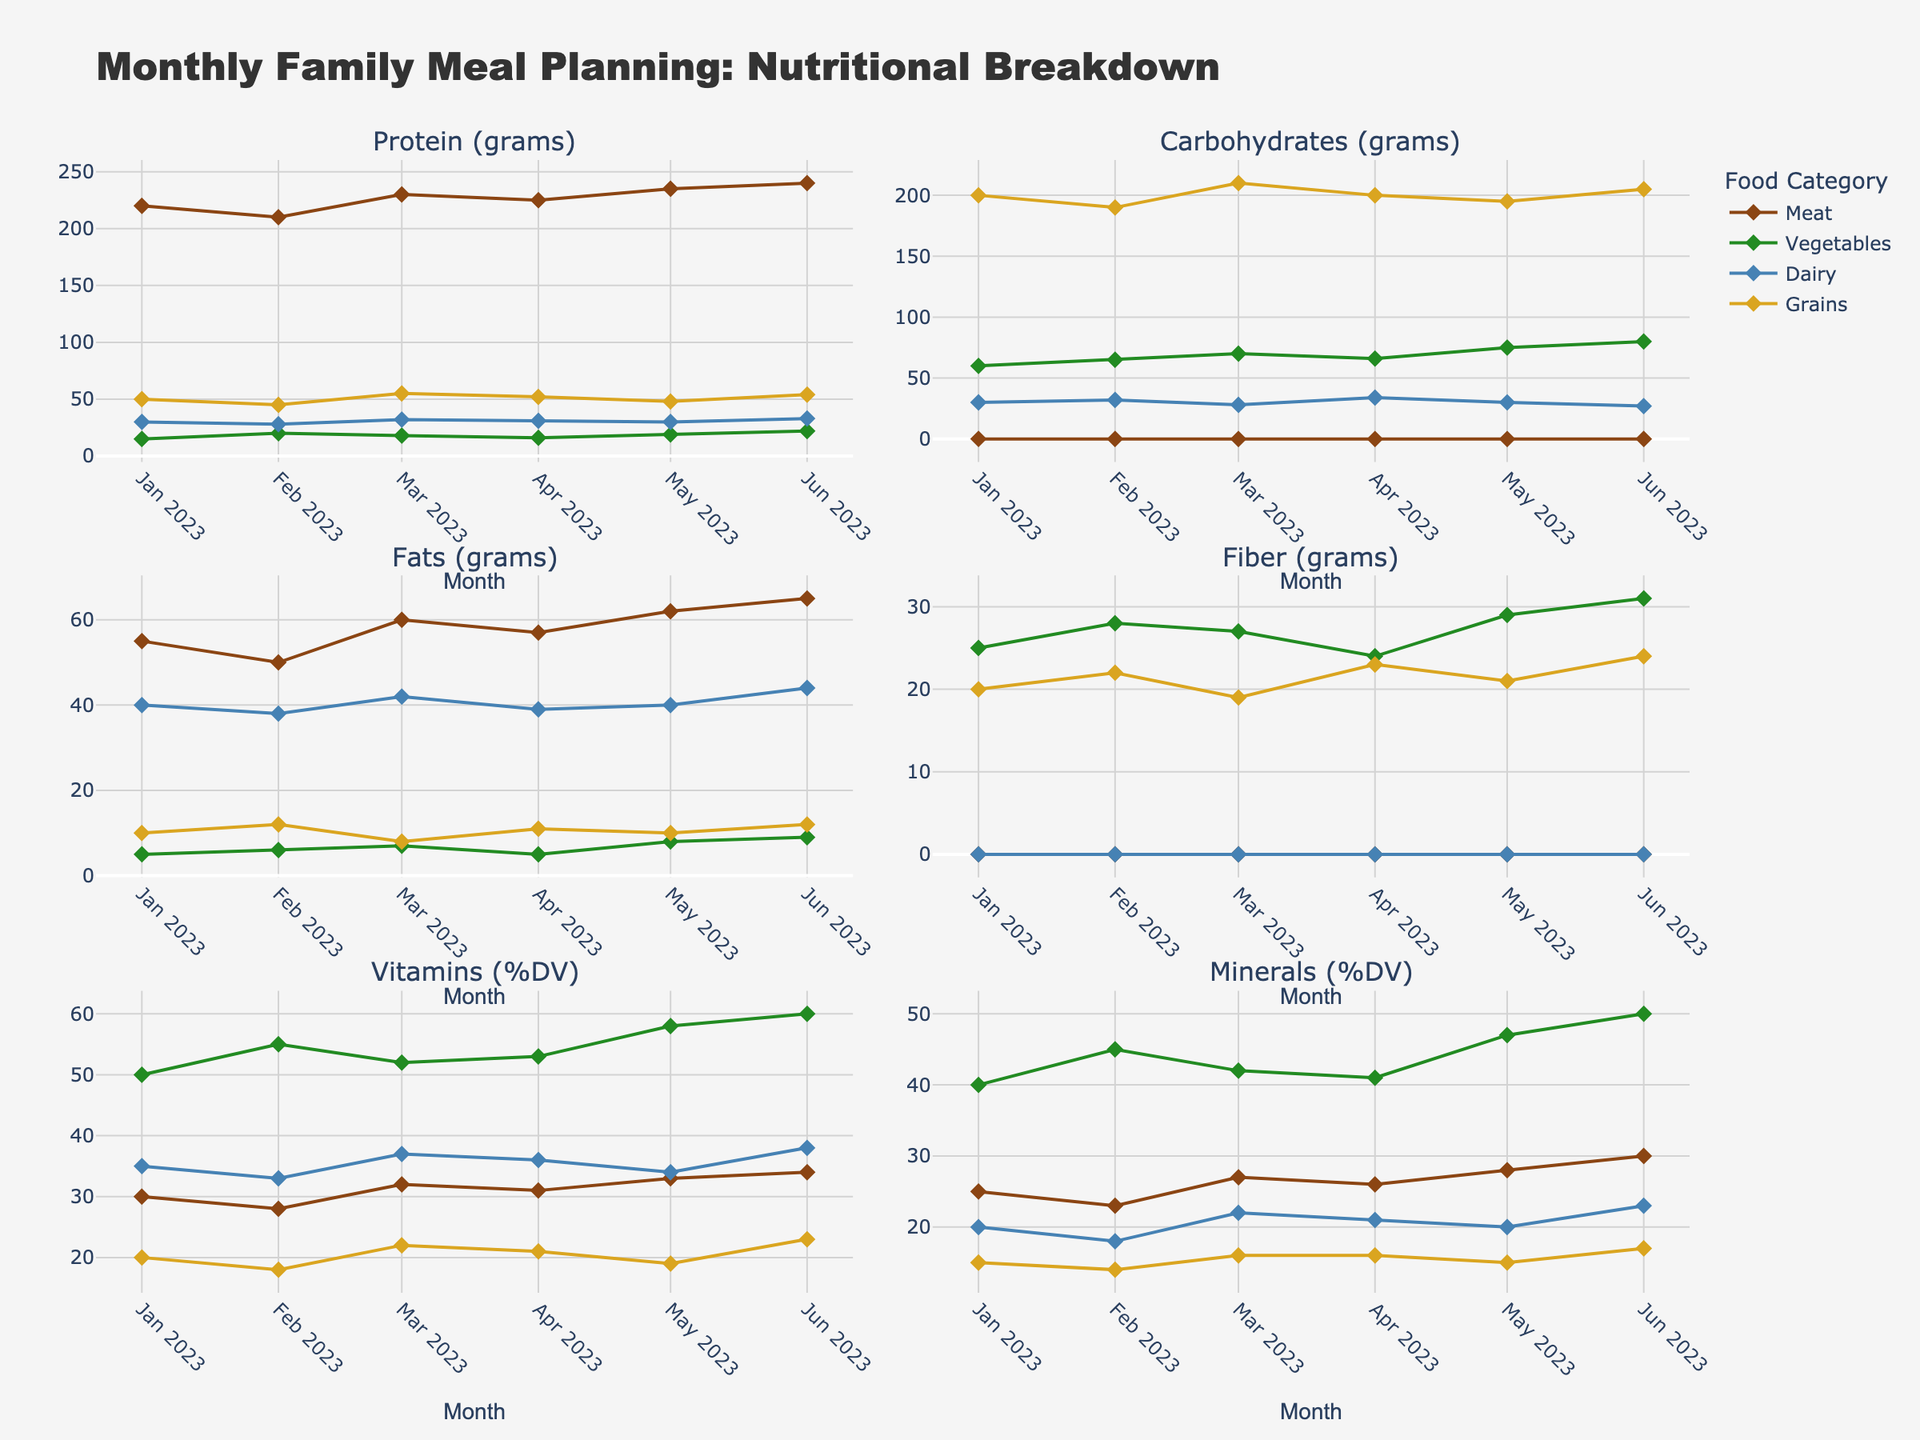What is the title of the figure? The title is typically located at the top of the figure, clearly summarizing the visual content. In this case, it reads "Monthly Family Meal Planning: Nutritional Breakdown".
Answer: Monthly Family Meal Planning: Nutritional Breakdown Which food category has the highest protein content in May 2023? Look at the subplot for "Protein (grams)" and examine the data points for May 2023. The category with the highest y-value indicates the highest protein content.
Answer: Meat In which month did vegetables have the highest amount of fiber? Locate the subplot for "Fiber (grams)" and track the data points corresponding to vegetables (green line). Identify the peak value's month along this line.
Answer: June 2023 What is the average amount of carbohydrates from grains over the six months? Add the carbohydrate values for grains from January to June (200 + 190 + 210 + 200 + 195 + 205), then divide by 6.
Answer: 200 grams Which food category showed a decreasing trend in fat content from January to June 2023? Examine the subplot for "Fats (grams)" and trace the trend lines for each category. Determine which line generally moves downwards from January to June 2023.
Answer: Dairy Compare the vitamin content (%DV) in meat and vegetables in March 2023. Which is higher? In the "Vitamins (%DV)" subplot, find the data points for meat and vegetables in March 2023. Compare the y-values of these two points.
Answer: Vegetables How does the mineral content (%DV) change for dairy from January to June 2023? In the "Minerals (%DV)" subplot, follow the data points for dairy across the months. Observe if the values increase, decrease, or vary.
Answer: Generally increases In which month did grains have the lowest protein content? Locate the subplot for "Protein (grams)" and trace the line corresponding to grains. Identify the month with the lowest data point on this line.
Answer: February 2023 What is the difference in carbohydrate content between vegetables and grains in June 2023? On the "Carbohydrates (grams)" subplot, note the carbohydrate values for vegetables and grains in June 2023. Subtract the value for vegetables from grains.
Answer: 125 grams Which month had the highest overall fat content across all nutritional categories? For each month, sum the fat content values across all categories and compare the sums. The month with the highest cumulative value is the answer.
Answer: March 2023 